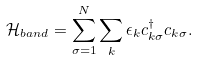Convert formula to latex. <formula><loc_0><loc_0><loc_500><loc_500>\mathcal { H } _ { b a n d } = \sum _ { \sigma = 1 } ^ { N } \sum _ { k } \epsilon _ { k } c ^ { \dagger } _ { k \sigma } c _ { k \sigma } .</formula> 